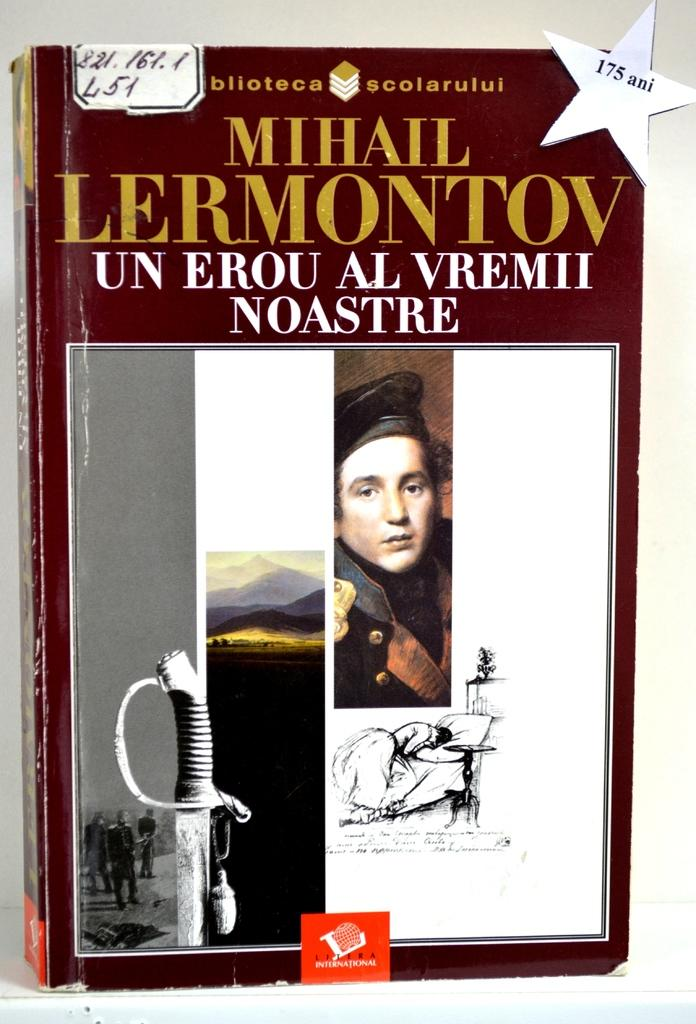<image>
Render a clear and concise summary of the photo. Book titled "Un Erou Al Vremii Noastre" showing a sword and a man's face on the cover. 